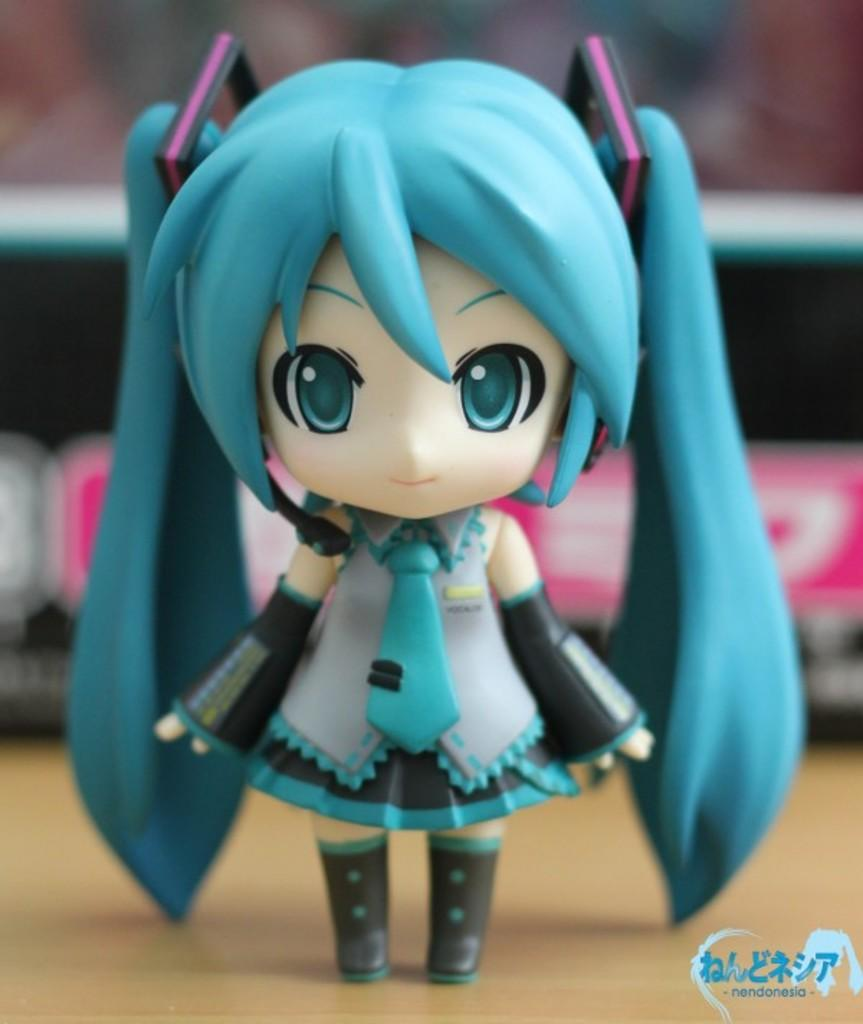What is the main subject of the image? There is a doll in the image. Where is the doll located? The doll is on a platform. Can you describe the background of the image? There are objects visible in the background of the image. What type of distribution system is being used by the doll in the image? There is no distribution system present in the image; it is a doll on a platform. What achievements has the doll accomplished in the image? The doll is an inanimate object and cannot accomplish achievements. 